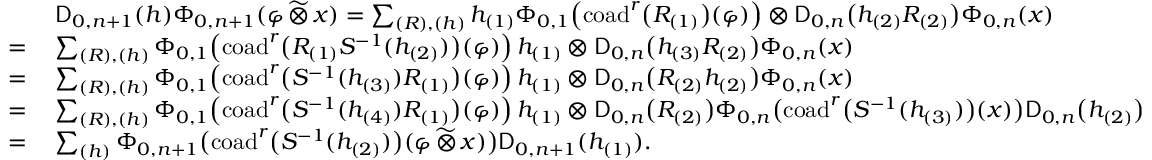<formula> <loc_0><loc_0><loc_500><loc_500>\begin{array} { r l } & { D _ { 0 , n + 1 } ( h ) \Phi _ { 0 , n + 1 } ( \varphi \, \widetilde { \otimes } \, x ) = \sum _ { ( R ) , ( h ) } h _ { ( 1 ) } \Phi _ { 0 , 1 } \, \left ( c o a d ^ { r } \left ( R _ { ( 1 ) } \right ) ( \varphi ) \right ) \otimes D _ { 0 , n } \left ( h _ { ( 2 ) } R _ { ( 2 ) } \right ) \Phi _ { 0 , n } ( x ) } \\ { = \, } & { \sum _ { ( R ) , ( h ) } \Phi _ { 0 , 1 } \, \left ( c o a d ^ { r } \left ( R _ { ( 1 ) } S ^ { - 1 } ( h _ { ( 2 ) } ) \right ) ( \varphi ) \right ) h _ { ( 1 ) } \otimes D _ { 0 , n } \left ( h _ { ( 3 ) } R _ { ( 2 ) } \right ) \Phi _ { 0 , n } ( x ) } \\ { = \, } & { \sum _ { ( R ) , ( h ) } \Phi _ { 0 , 1 } \, \left ( c o a d ^ { r } \left ( S ^ { - 1 } ( h _ { ( 3 ) } ) R _ { ( 1 ) } \right ) ( \varphi ) \right ) h _ { ( 1 ) } \otimes D _ { 0 , n } \left ( R _ { ( 2 ) } h _ { ( 2 ) } \right ) \Phi _ { 0 , n } ( x ) } \\ { = \, } & { \sum _ { ( R ) , ( h ) } \Phi _ { 0 , 1 } \, \left ( c o a d ^ { r } \left ( S ^ { - 1 } ( h _ { ( 4 ) } ) R _ { ( 1 ) } \right ) ( \varphi ) \right ) h _ { ( 1 ) } \otimes D _ { 0 , n } \left ( R _ { ( 2 ) } \right ) \Phi _ { 0 , n } \left ( c o a d ^ { r } \left ( S ^ { - 1 } ( h _ { ( 3 ) } ) \right ) ( x ) \right ) D _ { 0 , n } \left ( h _ { ( 2 ) } \right ) } \\ { = \, } & { \sum _ { ( h ) } \Phi _ { 0 , n + 1 } \left ( c o a d ^ { r } \left ( S ^ { - 1 } ( h _ { ( 2 ) } ) \right ) ( \varphi \, \widetilde { \otimes } \, x ) \right ) D _ { 0 , n + 1 } ( h _ { ( 1 ) } ) . } \end{array}</formula> 